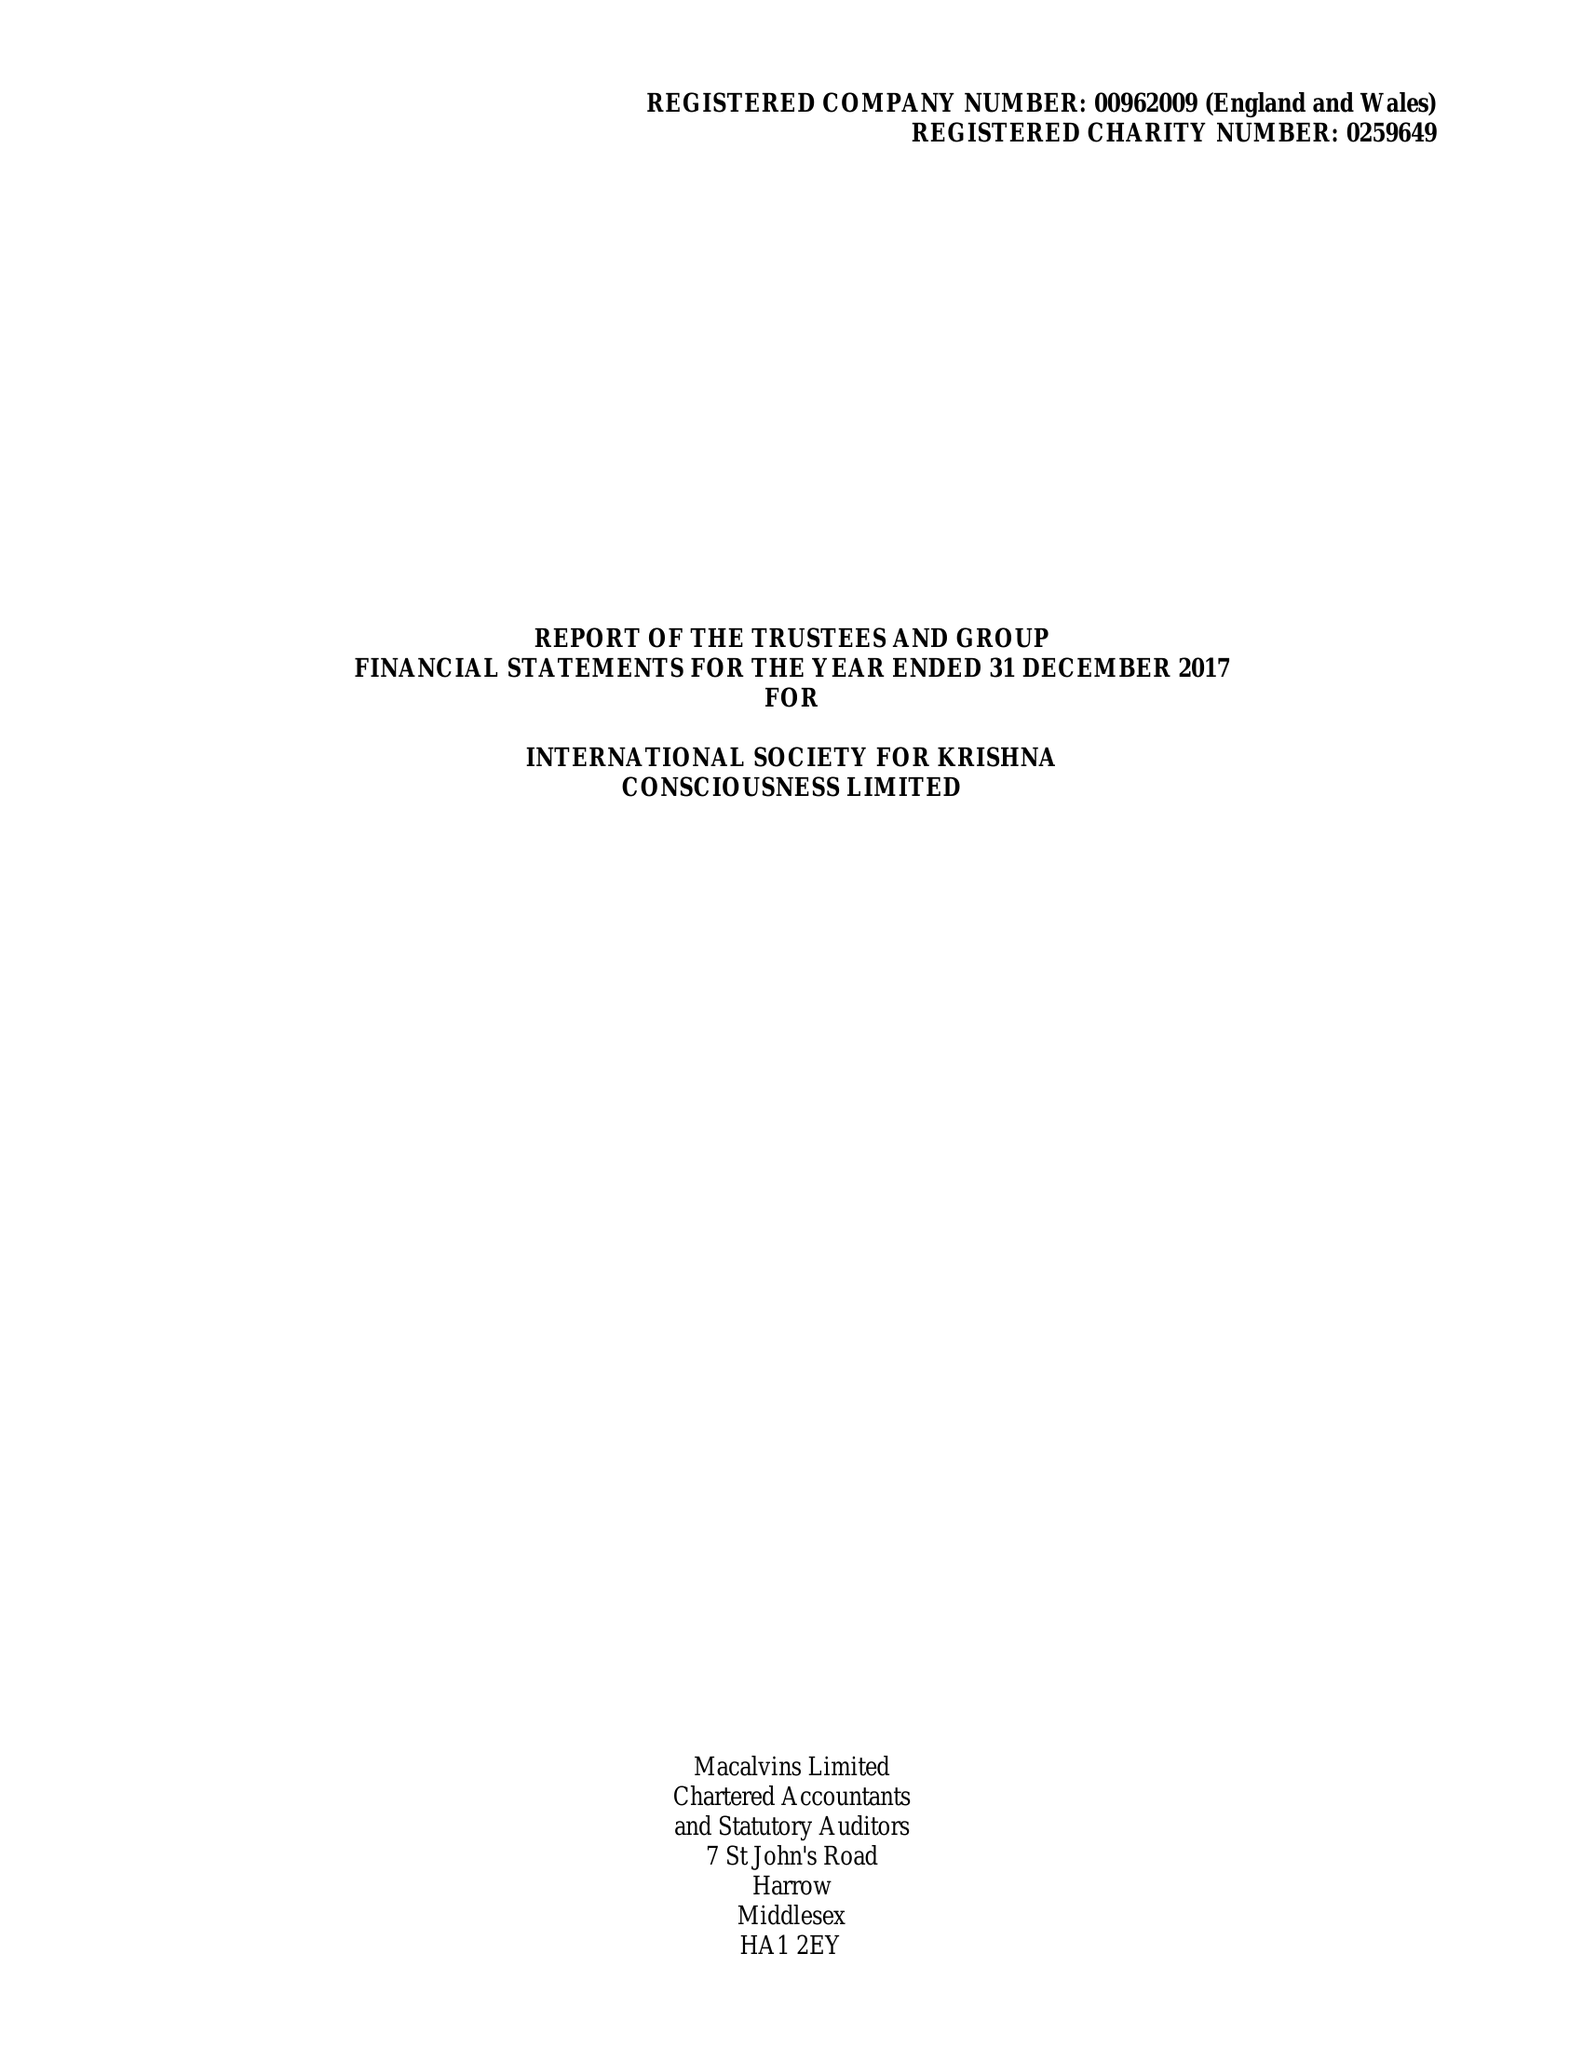What is the value for the spending_annually_in_british_pounds?
Answer the question using a single word or phrase. 7884769.00 